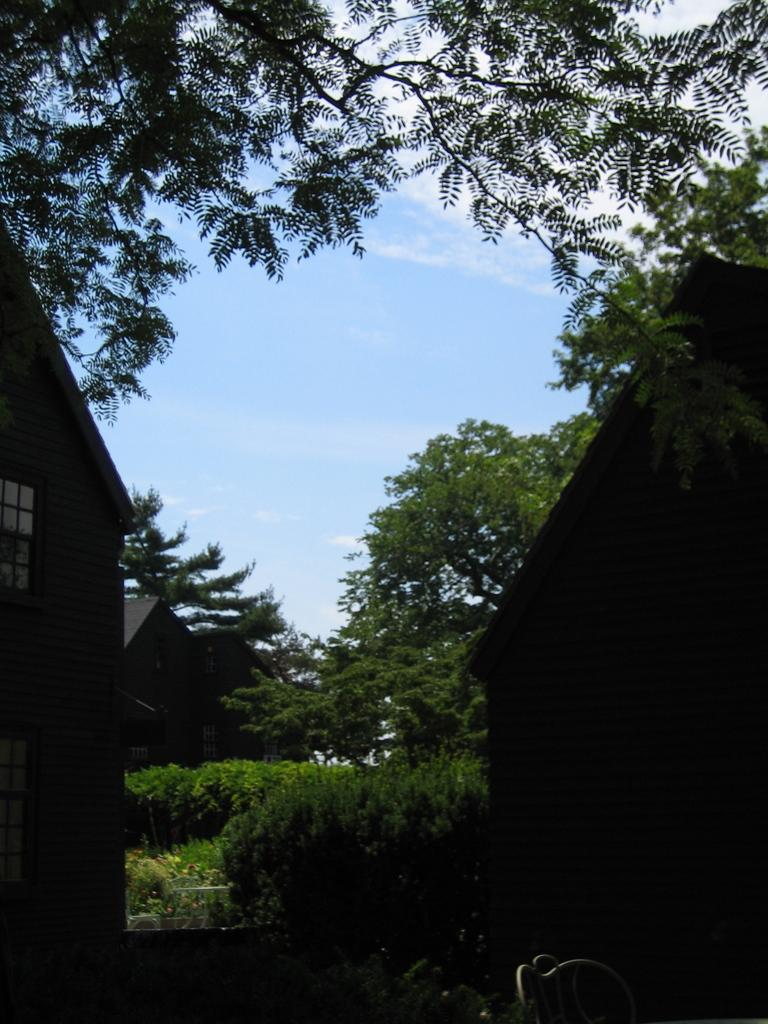What type of structures can be seen in the picture? There are houses in the picture. What type of vegetation is present in the picture? There are trees and plants in the picture. What can be seen in the background of the picture? The sky is visible in the background of the picture. How many losses can be counted in the picture? There is no reference to any losses in the picture, as it features houses, trees, plants, and the sky. 